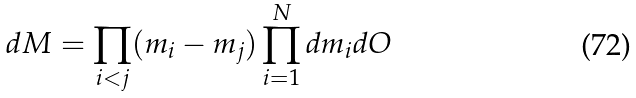Convert formula to latex. <formula><loc_0><loc_0><loc_500><loc_500>d M = \prod _ { i < j } ( m _ { i } - m _ { j } ) \prod _ { i = 1 } ^ { N } d m _ { i } d O</formula> 